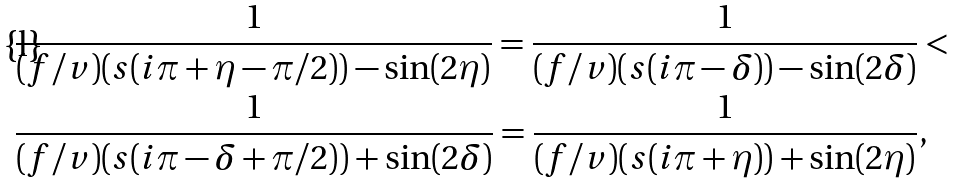Convert formula to latex. <formula><loc_0><loc_0><loc_500><loc_500>& \frac { 1 } { ( f / v ) ( s ( i \pi + \eta - \pi / 2 ) ) - \sin ( 2 \eta ) } = \frac { 1 } { ( f / v ) ( s ( i \pi - \delta ) ) - \sin ( 2 \delta ) } < \\ & \frac { 1 } { ( f / v ) ( s ( i \pi - \delta + \pi / 2 ) ) + \sin ( 2 \delta ) } = \frac { 1 } { ( f / v ) ( s ( i \pi + \eta ) ) + \sin ( 2 \eta ) } ,</formula> 